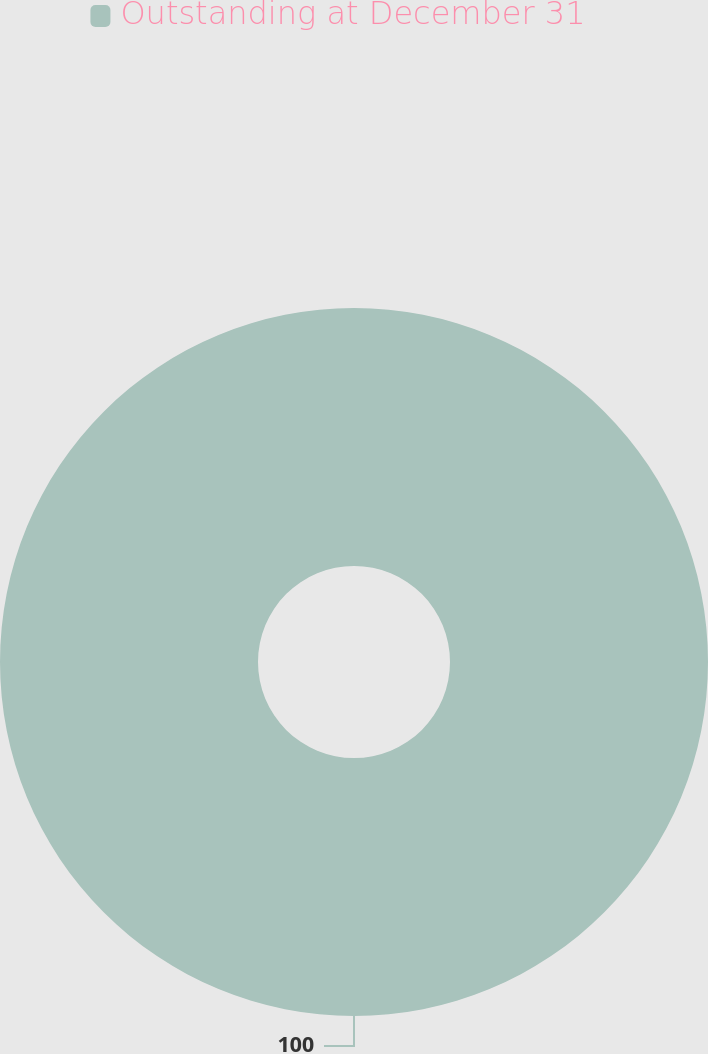Convert chart. <chart><loc_0><loc_0><loc_500><loc_500><pie_chart><fcel>Outstanding at December 31<nl><fcel>100.0%<nl></chart> 